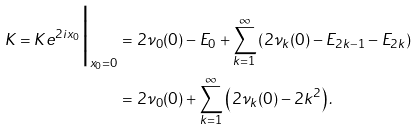Convert formula to latex. <formula><loc_0><loc_0><loc_500><loc_500>K = K e ^ { 2 i x _ { 0 } } \Big | _ { x _ { 0 } = 0 } & = 2 \nu _ { 0 } ( 0 ) - E _ { 0 } + \sum _ { k = 1 } ^ { \infty } \left ( 2 \nu _ { k } ( 0 ) - E _ { 2 k - 1 } - E _ { 2 k } \right ) \\ & = 2 \nu _ { 0 } ( 0 ) + \sum _ { k = 1 } ^ { \infty } \left ( 2 \nu _ { k } ( 0 ) - 2 k ^ { 2 } \right ) .</formula> 